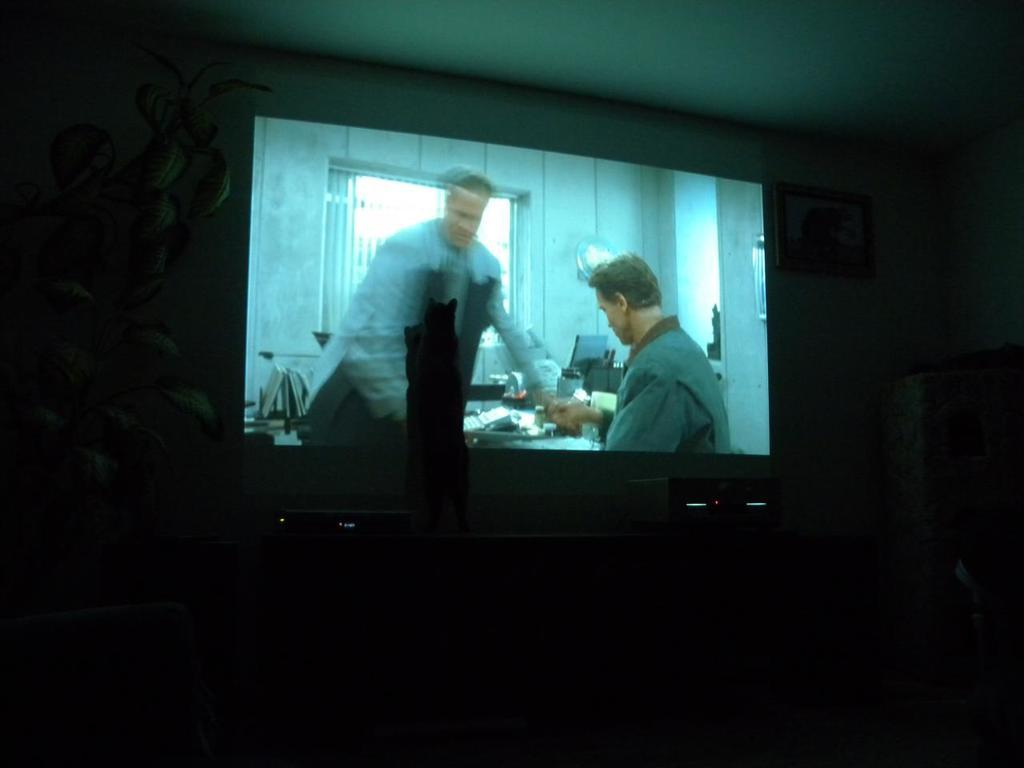What is the main object in the image? There is a display screen in the image. What can be seen on the left side of the image? There is a plant on the left side of the image. What is hanging on the wall in the image? There appears to be a photo frame on the wall in the image. What is located on the right side of the image? There is a cupboard on the right side of the image. How many mice are visible on the display screen in the image? There are no mice visible on the display screen in the image. What type of guide is present in the image? There is no guide present in the image. 